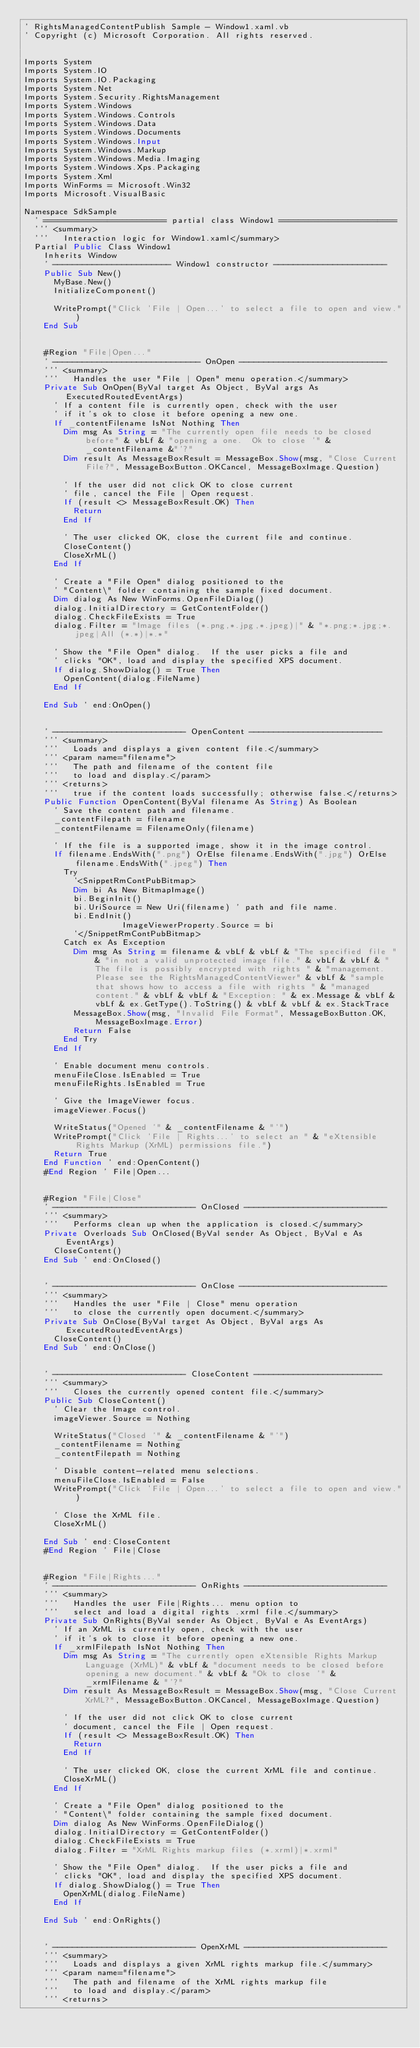<code> <loc_0><loc_0><loc_500><loc_500><_VisualBasic_>' RightsManagedContentPublish Sample - Window1.xaml.vb
' Copyright (c) Microsoft Corporation. All rights reserved.


Imports System
Imports System.IO
Imports System.IO.Packaging
Imports System.Net
Imports System.Security.RightsManagement
Imports System.Windows
Imports System.Windows.Controls
Imports System.Windows.Data
Imports System.Windows.Documents
Imports System.Windows.Input
Imports System.Windows.Markup
Imports System.Windows.Media.Imaging
Imports System.Windows.Xps.Packaging
Imports System.Xml
Imports WinForms = Microsoft.Win32
Imports Microsoft.VisualBasic

Namespace SdkSample
	' ========================= partial class Window1 ========================
	''' <summary>
	'''   Interaction logic for Window1.xaml</summary>
	Partial Public Class Window1
		Inherits Window
		' ------------------------ Window1 constructor -----------------------
		Public Sub New()
			MyBase.New()
			InitializeComponent()

			WritePrompt("Click 'File | Open...' to select a file to open and view.")
		End Sub


		#Region "File|Open..."
		' ------------------------------ OnOpen ------------------------------
		''' <summary>
		'''   Handles the user "File | Open" menu operation.</summary>
		Private Sub OnOpen(ByVal target As Object, ByVal args As ExecutedRoutedEventArgs)
			' If a content file is currently open, check with the user
			' if it's ok to close it before opening a new one.
			If _contentFilename IsNot Nothing Then
				Dim msg As String = "The currently open file needs to be closed before" & vbLf & "opening a one.  Ok to close '" & _contentFilename &"'?"
				Dim result As MessageBoxResult = MessageBox.Show(msg, "Close Current File?", MessageBoxButton.OKCancel, MessageBoxImage.Question)

				' If the user did not click OK to close current
				' file, cancel the File | Open request.
				If (result <> MessageBoxResult.OK) Then
					Return
				End If

				' The user clicked OK, close the current file and continue.
				CloseContent()
				CloseXrML()
			End If

			' Create a "File Open" dialog positioned to the
			' "Content\" folder containing the sample fixed document.
			Dim dialog As New WinForms.OpenFileDialog()
			dialog.InitialDirectory = GetContentFolder()
			dialog.CheckFileExists = True
			dialog.Filter = "Image files (*.png,*.jpg,*.jpeg)|" & "*.png;*.jpg;*.jpeg|All (*.*)|*.*"

			' Show the "File Open" dialog.  If the user picks a file and
			' clicks "OK", load and display the specified XPS document.
			If dialog.ShowDialog() = True Then
				OpenContent(dialog.FileName)
			End If

		End Sub ' end:OnOpen()


		' --------------------------- OpenContent ---------------------------
		''' <summary>
		'''   Loads and displays a given content file.</summary>
		''' <param name="filename">
		'''   The path and filename of the content file
		'''   to load and display.</param>
		''' <returns>
		'''   true if the content loads successfully; otherwise false.</returns>
		Public Function OpenContent(ByVal filename As String) As Boolean
			' Save the content path and filename.
			_contentFilepath = filename
			_contentFilename = FilenameOnly(filename)

			' If the file is a supported image, show it in the image control.
			If filename.EndsWith(".png") OrElse filename.EndsWith(".jpg") OrElse filename.EndsWith(".jpeg") Then
				Try
					'<SnippetRmContPubBitmap>
					Dim bi As New BitmapImage()
					bi.BeginInit()
					bi.UriSource = New Uri(filename) ' path and file name.
					bi.EndInit()
                    ImageViewerProperty.Source = bi
					'</SnippetRmContPubBitmap>
				Catch ex As Exception
					Dim msg As String = filename & vbLf & vbLf & "The specified file " & "in not a valid unprotected image file." & vbLf & vbLf & "The file is possibly encrypted with rights " & "management.  Please see the RightsManagedContentViewer" & vbLf & "sample that shows how to access a file with rights " & "managed content." & vbLf & vbLf & "Exception: " & ex.Message & vbLf & vbLf & ex.GetType().ToString() & vbLf & vbLf & ex.StackTrace
					MessageBox.Show(msg, "Invalid File Format", MessageBoxButton.OK, MessageBoxImage.Error)
					Return False
				End Try
			End If

			' Enable document menu controls.
			menuFileClose.IsEnabled = True
			menuFileRights.IsEnabled = True

			' Give the ImageViewer focus.
			imageViewer.Focus()

			WriteStatus("Opened '" & _contentFilename & "'")
			WritePrompt("Click 'File | Rights...' to select an " & "eXtensible Rights Markup (XrML) permissions file.")
			Return True
		End Function ' end:OpenContent()
		#End Region ' File|Open...


		#Region "File|Close"
		' ----------------------------- OnClosed -----------------------------
		''' <summary>
		'''   Performs clean up when the application is closed.</summary>
		Private Overloads Sub OnClosed(ByVal sender As Object, ByVal e As EventArgs)
			CloseContent()
		End Sub ' end:OnClosed()


		' ----------------------------- OnClose ------------------------------
		''' <summary>
		'''   Handles the user "File | Close" menu operation
		'''   to close the currently open document.</summary>
		Private Sub OnClose(ByVal target As Object, ByVal args As ExecutedRoutedEventArgs)
			CloseContent()
		End Sub ' end:OnClose()


		' --------------------------- CloseContent --------------------------
		''' <summary>
		'''   Closes the currently opened content file.</summary>
		Public Sub CloseContent()
			' Clear the Image control.
			imageViewer.Source = Nothing

			WriteStatus("Closed '" & _contentFilename & "'")
			_contentFilename = Nothing
			_contentFilepath = Nothing

			' Disable content-related menu selections.
			menuFileClose.IsEnabled = False
			WritePrompt("Click 'File | Open...' to select a file to open and view.")

			' Close the XrML file.
			CloseXrML()

		End Sub ' end:CloseContent
		#End Region ' File|Close


		#Region "File|Rights..."
		' ----------------------------- OnRights -----------------------------
		''' <summary>
		'''   Handles the user File|Rights... menu option to
		'''   select and load a digital rights .xrml file.</summary>
		Private Sub OnRights(ByVal sender As Object, ByVal e As EventArgs)
			' If an XrML is currently open, check with the user
			' if it's ok to close it before opening a new one.
			If _xrmlFilepath IsNot Nothing Then
				Dim msg As String = "The currently open eXtensible Rights Markup Language (XrML)" & vbLf & "document needs to be closed before opening a new document." & vbLf & "Ok to close '" & _xrmlFilename & "'?"
				Dim result As MessageBoxResult = MessageBox.Show(msg, "Close Current XrML?", MessageBoxButton.OKCancel, MessageBoxImage.Question)

				' If the user did not click OK to close current
				' document, cancel the File | Open request.
				If (result <> MessageBoxResult.OK) Then
					Return
				End If

				' The user clicked OK, close the current XrML file and continue.
				CloseXrML()
			End If

			' Create a "File Open" dialog positioned to the
			' "Content\" folder containing the sample fixed document.
			Dim dialog As New WinForms.OpenFileDialog()
			dialog.InitialDirectory = GetContentFolder()
			dialog.CheckFileExists = True
			dialog.Filter = "XrML Rights markup files (*.xrml)|*.xrml"

			' Show the "File Open" dialog.  If the user picks a file and
			' clicks "OK", load and display the specified XPS document.
			If dialog.ShowDialog() = True Then
				OpenXrML(dialog.FileName)
			End If

		End Sub ' end:OnRights()


		' ----------------------------- OpenXrML -----------------------------
		''' <summary>
		'''   Loads and displays a given XrML rights markup file.</summary>
		''' <param name="filename">
		'''   The path and filename of the XrML rights markup file
		'''   to load and display.</param>
		''' <returns></code> 